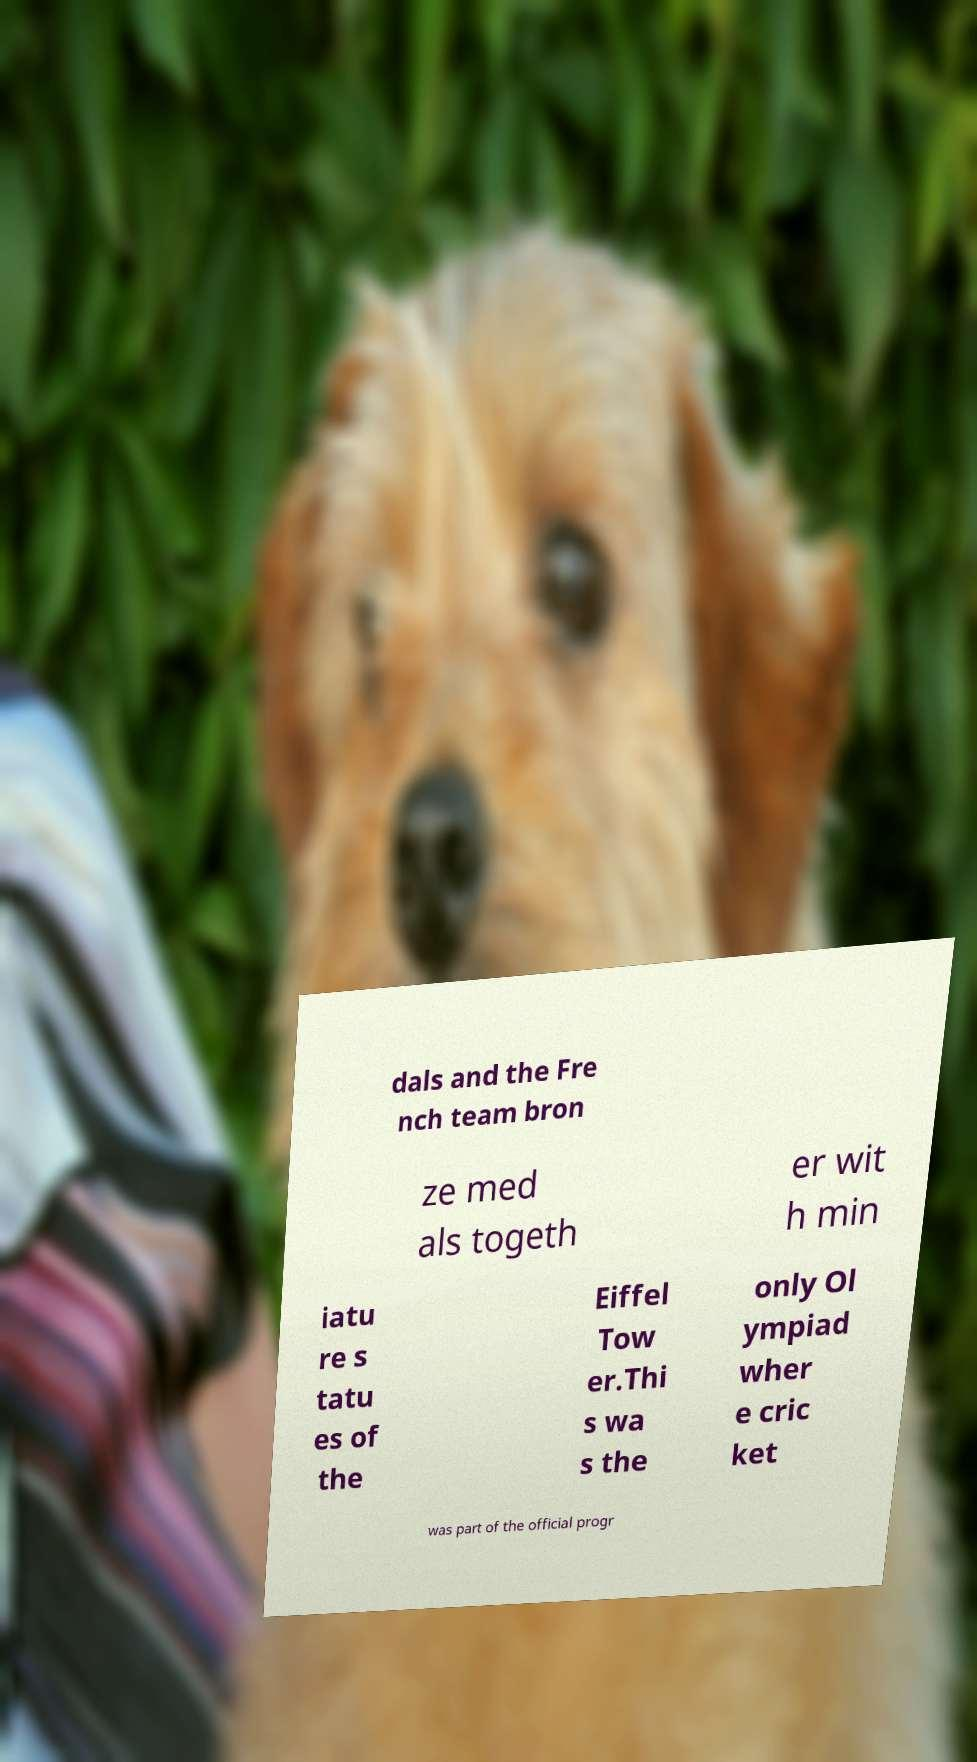Could you extract and type out the text from this image? dals and the Fre nch team bron ze med als togeth er wit h min iatu re s tatu es of the Eiffel Tow er.Thi s wa s the only Ol ympiad wher e cric ket was part of the official progr 